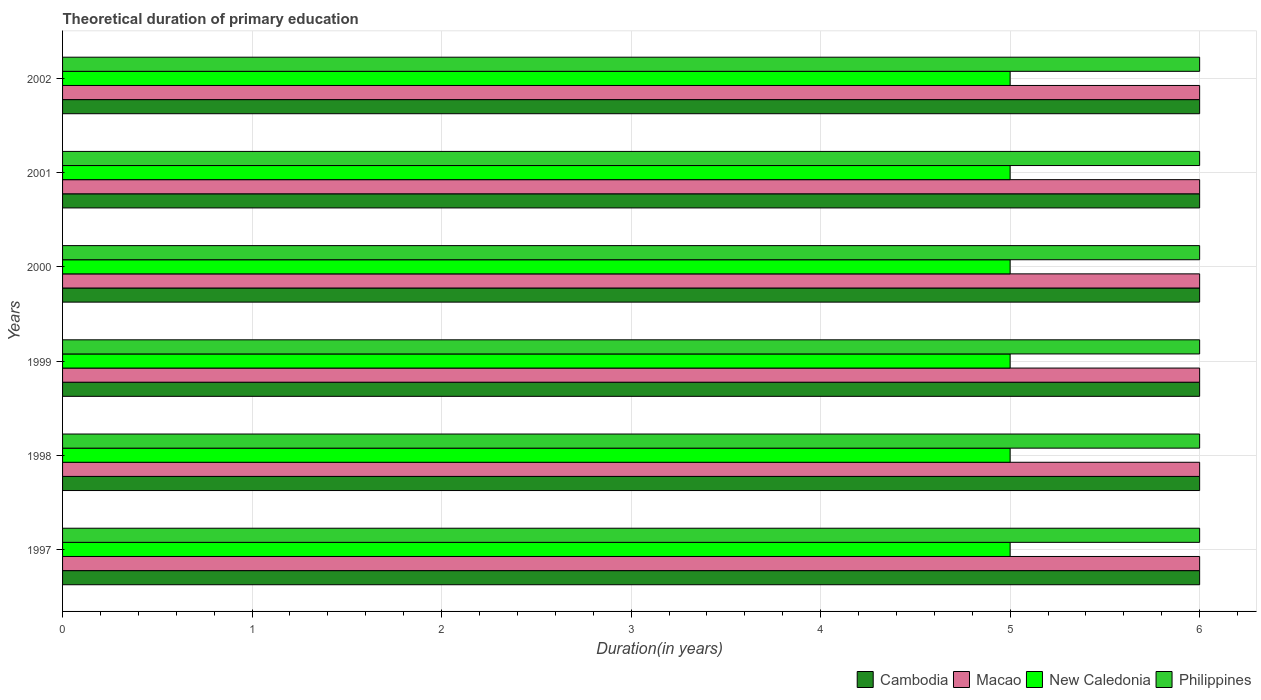Are the number of bars per tick equal to the number of legend labels?
Make the answer very short. Yes. How many bars are there on the 1st tick from the bottom?
Keep it short and to the point. 4. What is the label of the 1st group of bars from the top?
Your answer should be very brief. 2002. Across all years, what is the minimum total theoretical duration of primary education in New Caledonia?
Offer a very short reply. 5. In which year was the total theoretical duration of primary education in Macao maximum?
Make the answer very short. 1997. In which year was the total theoretical duration of primary education in Macao minimum?
Your response must be concise. 1997. What is the total total theoretical duration of primary education in Philippines in the graph?
Give a very brief answer. 36. What is the difference between the total theoretical duration of primary education in Cambodia in 1998 and the total theoretical duration of primary education in Philippines in 1999?
Give a very brief answer. 0. In the year 2000, what is the difference between the total theoretical duration of primary education in Macao and total theoretical duration of primary education in Philippines?
Your response must be concise. 0. In how many years, is the total theoretical duration of primary education in New Caledonia greater than 4 years?
Your answer should be very brief. 6. Is the total theoretical duration of primary education in New Caledonia in 1997 less than that in 2001?
Your response must be concise. No. What is the difference between the highest and the lowest total theoretical duration of primary education in New Caledonia?
Your answer should be very brief. 0. Is it the case that in every year, the sum of the total theoretical duration of primary education in Philippines and total theoretical duration of primary education in New Caledonia is greater than the sum of total theoretical duration of primary education in Cambodia and total theoretical duration of primary education in Macao?
Provide a succinct answer. No. What does the 4th bar from the top in 1998 represents?
Make the answer very short. Cambodia. What does the 2nd bar from the bottom in 2000 represents?
Keep it short and to the point. Macao. Are all the bars in the graph horizontal?
Ensure brevity in your answer.  Yes. How many years are there in the graph?
Keep it short and to the point. 6. Are the values on the major ticks of X-axis written in scientific E-notation?
Your answer should be very brief. No. Does the graph contain grids?
Offer a terse response. Yes. Where does the legend appear in the graph?
Make the answer very short. Bottom right. What is the title of the graph?
Your answer should be very brief. Theoretical duration of primary education. What is the label or title of the X-axis?
Provide a short and direct response. Duration(in years). What is the Duration(in years) of Cambodia in 1997?
Keep it short and to the point. 6. What is the Duration(in years) of Macao in 1997?
Your answer should be compact. 6. What is the Duration(in years) in Philippines in 1997?
Your response must be concise. 6. What is the Duration(in years) in Cambodia in 1998?
Your response must be concise. 6. What is the Duration(in years) in New Caledonia in 1998?
Offer a terse response. 5. What is the Duration(in years) in Cambodia in 1999?
Make the answer very short. 6. What is the Duration(in years) of Macao in 1999?
Ensure brevity in your answer.  6. What is the Duration(in years) in Cambodia in 2000?
Make the answer very short. 6. What is the Duration(in years) in Cambodia in 2001?
Your response must be concise. 6. What is the Duration(in years) in Macao in 2001?
Ensure brevity in your answer.  6. What is the Duration(in years) in New Caledonia in 2001?
Make the answer very short. 5. What is the Duration(in years) of Cambodia in 2002?
Offer a very short reply. 6. What is the Duration(in years) in New Caledonia in 2002?
Your answer should be very brief. 5. Across all years, what is the maximum Duration(in years) in Macao?
Provide a short and direct response. 6. Across all years, what is the maximum Duration(in years) of New Caledonia?
Keep it short and to the point. 5. Across all years, what is the maximum Duration(in years) in Philippines?
Keep it short and to the point. 6. What is the total Duration(in years) in Macao in the graph?
Provide a short and direct response. 36. What is the total Duration(in years) in Philippines in the graph?
Your answer should be compact. 36. What is the difference between the Duration(in years) in Cambodia in 1997 and that in 1998?
Your answer should be compact. 0. What is the difference between the Duration(in years) in Macao in 1997 and that in 1998?
Your response must be concise. 0. What is the difference between the Duration(in years) of Philippines in 1997 and that in 1998?
Give a very brief answer. 0. What is the difference between the Duration(in years) of Cambodia in 1997 and that in 1999?
Provide a short and direct response. 0. What is the difference between the Duration(in years) in Macao in 1997 and that in 1999?
Make the answer very short. 0. What is the difference between the Duration(in years) in Philippines in 1997 and that in 1999?
Your answer should be compact. 0. What is the difference between the Duration(in years) in Philippines in 1997 and that in 2000?
Your response must be concise. 0. What is the difference between the Duration(in years) in Cambodia in 1997 and that in 2001?
Give a very brief answer. 0. What is the difference between the Duration(in years) of Macao in 1997 and that in 2001?
Offer a terse response. 0. What is the difference between the Duration(in years) of Philippines in 1997 and that in 2001?
Your answer should be compact. 0. What is the difference between the Duration(in years) in Cambodia in 1997 and that in 2002?
Give a very brief answer. 0. What is the difference between the Duration(in years) of Macao in 1997 and that in 2002?
Make the answer very short. 0. What is the difference between the Duration(in years) of New Caledonia in 1997 and that in 2002?
Provide a short and direct response. 0. What is the difference between the Duration(in years) of Cambodia in 1998 and that in 1999?
Offer a terse response. 0. What is the difference between the Duration(in years) in New Caledonia in 1998 and that in 1999?
Offer a very short reply. 0. What is the difference between the Duration(in years) in Macao in 1998 and that in 2001?
Give a very brief answer. 0. What is the difference between the Duration(in years) in Cambodia in 1998 and that in 2002?
Give a very brief answer. 0. What is the difference between the Duration(in years) in Macao in 1998 and that in 2002?
Your answer should be compact. 0. What is the difference between the Duration(in years) in New Caledonia in 1998 and that in 2002?
Give a very brief answer. 0. What is the difference between the Duration(in years) in Macao in 1999 and that in 2000?
Your response must be concise. 0. What is the difference between the Duration(in years) in Macao in 1999 and that in 2001?
Provide a succinct answer. 0. What is the difference between the Duration(in years) in New Caledonia in 1999 and that in 2001?
Offer a terse response. 0. What is the difference between the Duration(in years) in Philippines in 1999 and that in 2001?
Provide a short and direct response. 0. What is the difference between the Duration(in years) in Philippines in 1999 and that in 2002?
Offer a terse response. 0. What is the difference between the Duration(in years) in New Caledonia in 2000 and that in 2001?
Provide a short and direct response. 0. What is the difference between the Duration(in years) in Philippines in 2000 and that in 2001?
Make the answer very short. 0. What is the difference between the Duration(in years) in Cambodia in 2000 and that in 2002?
Your response must be concise. 0. What is the difference between the Duration(in years) in New Caledonia in 2000 and that in 2002?
Give a very brief answer. 0. What is the difference between the Duration(in years) in Philippines in 2000 and that in 2002?
Keep it short and to the point. 0. What is the difference between the Duration(in years) in Cambodia in 2001 and that in 2002?
Your answer should be compact. 0. What is the difference between the Duration(in years) of Macao in 2001 and that in 2002?
Your response must be concise. 0. What is the difference between the Duration(in years) of Philippines in 2001 and that in 2002?
Provide a short and direct response. 0. What is the difference between the Duration(in years) in Cambodia in 1997 and the Duration(in years) in Philippines in 1998?
Your answer should be compact. 0. What is the difference between the Duration(in years) in Macao in 1997 and the Duration(in years) in Philippines in 1998?
Your answer should be compact. 0. What is the difference between the Duration(in years) of New Caledonia in 1997 and the Duration(in years) of Philippines in 1998?
Keep it short and to the point. -1. What is the difference between the Duration(in years) of Cambodia in 1997 and the Duration(in years) of New Caledonia in 1999?
Your answer should be compact. 1. What is the difference between the Duration(in years) in Cambodia in 1997 and the Duration(in years) in Philippines in 1999?
Provide a succinct answer. 0. What is the difference between the Duration(in years) of Macao in 1997 and the Duration(in years) of Philippines in 1999?
Offer a terse response. 0. What is the difference between the Duration(in years) in New Caledonia in 1997 and the Duration(in years) in Philippines in 1999?
Provide a succinct answer. -1. What is the difference between the Duration(in years) in Cambodia in 1997 and the Duration(in years) in New Caledonia in 2000?
Your answer should be compact. 1. What is the difference between the Duration(in years) of Macao in 1997 and the Duration(in years) of New Caledonia in 2000?
Make the answer very short. 1. What is the difference between the Duration(in years) of Cambodia in 1997 and the Duration(in years) of Macao in 2001?
Keep it short and to the point. 0. What is the difference between the Duration(in years) of Cambodia in 1997 and the Duration(in years) of New Caledonia in 2001?
Offer a very short reply. 1. What is the difference between the Duration(in years) in Cambodia in 1997 and the Duration(in years) in Philippines in 2001?
Provide a short and direct response. 0. What is the difference between the Duration(in years) in Macao in 1997 and the Duration(in years) in New Caledonia in 2001?
Your answer should be very brief. 1. What is the difference between the Duration(in years) in Cambodia in 1998 and the Duration(in years) in Philippines in 1999?
Your answer should be very brief. 0. What is the difference between the Duration(in years) in New Caledonia in 1998 and the Duration(in years) in Philippines in 1999?
Your response must be concise. -1. What is the difference between the Duration(in years) of Macao in 1998 and the Duration(in years) of New Caledonia in 2000?
Your answer should be very brief. 1. What is the difference between the Duration(in years) in New Caledonia in 1998 and the Duration(in years) in Philippines in 2000?
Give a very brief answer. -1. What is the difference between the Duration(in years) in Macao in 1998 and the Duration(in years) in New Caledonia in 2001?
Make the answer very short. 1. What is the difference between the Duration(in years) in New Caledonia in 1998 and the Duration(in years) in Philippines in 2001?
Keep it short and to the point. -1. What is the difference between the Duration(in years) of Cambodia in 1998 and the Duration(in years) of Macao in 2002?
Offer a very short reply. 0. What is the difference between the Duration(in years) of Macao in 1998 and the Duration(in years) of New Caledonia in 2002?
Make the answer very short. 1. What is the difference between the Duration(in years) of Macao in 1998 and the Duration(in years) of Philippines in 2002?
Give a very brief answer. 0. What is the difference between the Duration(in years) in New Caledonia in 1998 and the Duration(in years) in Philippines in 2002?
Keep it short and to the point. -1. What is the difference between the Duration(in years) in Cambodia in 1999 and the Duration(in years) in Macao in 2000?
Your answer should be compact. 0. What is the difference between the Duration(in years) of Cambodia in 1999 and the Duration(in years) of New Caledonia in 2000?
Ensure brevity in your answer.  1. What is the difference between the Duration(in years) in Macao in 1999 and the Duration(in years) in New Caledonia in 2000?
Ensure brevity in your answer.  1. What is the difference between the Duration(in years) in Cambodia in 1999 and the Duration(in years) in Macao in 2001?
Your answer should be compact. 0. What is the difference between the Duration(in years) in Cambodia in 1999 and the Duration(in years) in New Caledonia in 2001?
Provide a succinct answer. 1. What is the difference between the Duration(in years) of Macao in 1999 and the Duration(in years) of Philippines in 2001?
Ensure brevity in your answer.  0. What is the difference between the Duration(in years) of Cambodia in 1999 and the Duration(in years) of Macao in 2002?
Offer a terse response. 0. What is the difference between the Duration(in years) in New Caledonia in 1999 and the Duration(in years) in Philippines in 2002?
Ensure brevity in your answer.  -1. What is the difference between the Duration(in years) of Cambodia in 2000 and the Duration(in years) of Macao in 2001?
Ensure brevity in your answer.  0. What is the difference between the Duration(in years) in Cambodia in 2000 and the Duration(in years) in New Caledonia in 2001?
Ensure brevity in your answer.  1. What is the difference between the Duration(in years) in Macao in 2000 and the Duration(in years) in Philippines in 2001?
Keep it short and to the point. 0. What is the difference between the Duration(in years) in Cambodia in 2000 and the Duration(in years) in Macao in 2002?
Offer a terse response. 0. What is the difference between the Duration(in years) in Macao in 2000 and the Duration(in years) in New Caledonia in 2002?
Provide a succinct answer. 1. What is the difference between the Duration(in years) in Macao in 2000 and the Duration(in years) in Philippines in 2002?
Offer a very short reply. 0. What is the difference between the Duration(in years) in New Caledonia in 2000 and the Duration(in years) in Philippines in 2002?
Give a very brief answer. -1. What is the difference between the Duration(in years) of Cambodia in 2001 and the Duration(in years) of New Caledonia in 2002?
Give a very brief answer. 1. What is the difference between the Duration(in years) of Cambodia in 2001 and the Duration(in years) of Philippines in 2002?
Offer a terse response. 0. What is the difference between the Duration(in years) of Macao in 2001 and the Duration(in years) of New Caledonia in 2002?
Offer a very short reply. 1. What is the difference between the Duration(in years) in Macao in 2001 and the Duration(in years) in Philippines in 2002?
Keep it short and to the point. 0. What is the average Duration(in years) of Philippines per year?
Provide a succinct answer. 6. In the year 1997, what is the difference between the Duration(in years) of Cambodia and Duration(in years) of Macao?
Provide a succinct answer. 0. In the year 1997, what is the difference between the Duration(in years) in Cambodia and Duration(in years) in New Caledonia?
Your response must be concise. 1. In the year 1997, what is the difference between the Duration(in years) of Macao and Duration(in years) of New Caledonia?
Ensure brevity in your answer.  1. In the year 1997, what is the difference between the Duration(in years) in Macao and Duration(in years) in Philippines?
Your answer should be compact. 0. In the year 1998, what is the difference between the Duration(in years) of Cambodia and Duration(in years) of New Caledonia?
Provide a short and direct response. 1. In the year 1998, what is the difference between the Duration(in years) of Cambodia and Duration(in years) of Philippines?
Your answer should be very brief. 0. In the year 1998, what is the difference between the Duration(in years) in Macao and Duration(in years) in New Caledonia?
Keep it short and to the point. 1. In the year 1999, what is the difference between the Duration(in years) of Cambodia and Duration(in years) of New Caledonia?
Offer a terse response. 1. In the year 1999, what is the difference between the Duration(in years) in Cambodia and Duration(in years) in Philippines?
Make the answer very short. 0. In the year 1999, what is the difference between the Duration(in years) of Macao and Duration(in years) of New Caledonia?
Ensure brevity in your answer.  1. In the year 1999, what is the difference between the Duration(in years) in New Caledonia and Duration(in years) in Philippines?
Provide a succinct answer. -1. In the year 2000, what is the difference between the Duration(in years) in Cambodia and Duration(in years) in Macao?
Ensure brevity in your answer.  0. In the year 2000, what is the difference between the Duration(in years) in Cambodia and Duration(in years) in New Caledonia?
Offer a very short reply. 1. In the year 2001, what is the difference between the Duration(in years) of Cambodia and Duration(in years) of Macao?
Your response must be concise. 0. In the year 2001, what is the difference between the Duration(in years) in Cambodia and Duration(in years) in Philippines?
Give a very brief answer. 0. In the year 2001, what is the difference between the Duration(in years) of Macao and Duration(in years) of New Caledonia?
Your response must be concise. 1. In the year 2001, what is the difference between the Duration(in years) in New Caledonia and Duration(in years) in Philippines?
Give a very brief answer. -1. In the year 2002, what is the difference between the Duration(in years) in Cambodia and Duration(in years) in New Caledonia?
Offer a very short reply. 1. What is the ratio of the Duration(in years) in Cambodia in 1997 to that in 1998?
Provide a short and direct response. 1. What is the ratio of the Duration(in years) of Macao in 1997 to that in 1998?
Keep it short and to the point. 1. What is the ratio of the Duration(in years) of Macao in 1997 to that in 1999?
Make the answer very short. 1. What is the ratio of the Duration(in years) in Cambodia in 1997 to that in 2000?
Make the answer very short. 1. What is the ratio of the Duration(in years) of Macao in 1997 to that in 2000?
Your answer should be compact. 1. What is the ratio of the Duration(in years) of New Caledonia in 1997 to that in 2000?
Your answer should be compact. 1. What is the ratio of the Duration(in years) in Philippines in 1997 to that in 2000?
Your response must be concise. 1. What is the ratio of the Duration(in years) in Macao in 1997 to that in 2001?
Your answer should be very brief. 1. What is the ratio of the Duration(in years) of Macao in 1997 to that in 2002?
Your answer should be compact. 1. What is the ratio of the Duration(in years) of Philippines in 1997 to that in 2002?
Offer a terse response. 1. What is the ratio of the Duration(in years) in Macao in 1998 to that in 1999?
Provide a short and direct response. 1. What is the ratio of the Duration(in years) of New Caledonia in 1998 to that in 1999?
Provide a short and direct response. 1. What is the ratio of the Duration(in years) in Philippines in 1998 to that in 1999?
Keep it short and to the point. 1. What is the ratio of the Duration(in years) in Cambodia in 1998 to that in 2000?
Provide a succinct answer. 1. What is the ratio of the Duration(in years) of Philippines in 1998 to that in 2000?
Offer a terse response. 1. What is the ratio of the Duration(in years) of Macao in 1998 to that in 2001?
Provide a short and direct response. 1. What is the ratio of the Duration(in years) of Philippines in 1998 to that in 2001?
Offer a terse response. 1. What is the ratio of the Duration(in years) in Macao in 1998 to that in 2002?
Your response must be concise. 1. What is the ratio of the Duration(in years) of New Caledonia in 1998 to that in 2002?
Your answer should be compact. 1. What is the ratio of the Duration(in years) of Philippines in 1998 to that in 2002?
Your answer should be very brief. 1. What is the ratio of the Duration(in years) in Macao in 1999 to that in 2000?
Offer a very short reply. 1. What is the ratio of the Duration(in years) of New Caledonia in 1999 to that in 2000?
Make the answer very short. 1. What is the ratio of the Duration(in years) in Macao in 1999 to that in 2001?
Offer a terse response. 1. What is the ratio of the Duration(in years) of Philippines in 1999 to that in 2001?
Make the answer very short. 1. What is the ratio of the Duration(in years) in Cambodia in 1999 to that in 2002?
Give a very brief answer. 1. What is the ratio of the Duration(in years) in Macao in 2000 to that in 2001?
Give a very brief answer. 1. What is the ratio of the Duration(in years) of New Caledonia in 2000 to that in 2001?
Make the answer very short. 1. What is the ratio of the Duration(in years) in Philippines in 2000 to that in 2001?
Offer a very short reply. 1. What is the ratio of the Duration(in years) in New Caledonia in 2000 to that in 2002?
Your answer should be very brief. 1. What is the ratio of the Duration(in years) of Philippines in 2000 to that in 2002?
Give a very brief answer. 1. What is the ratio of the Duration(in years) of Cambodia in 2001 to that in 2002?
Provide a short and direct response. 1. What is the ratio of the Duration(in years) of Macao in 2001 to that in 2002?
Your response must be concise. 1. What is the ratio of the Duration(in years) of New Caledonia in 2001 to that in 2002?
Offer a terse response. 1. What is the difference between the highest and the second highest Duration(in years) in Macao?
Offer a very short reply. 0. What is the difference between the highest and the lowest Duration(in years) of New Caledonia?
Give a very brief answer. 0. 